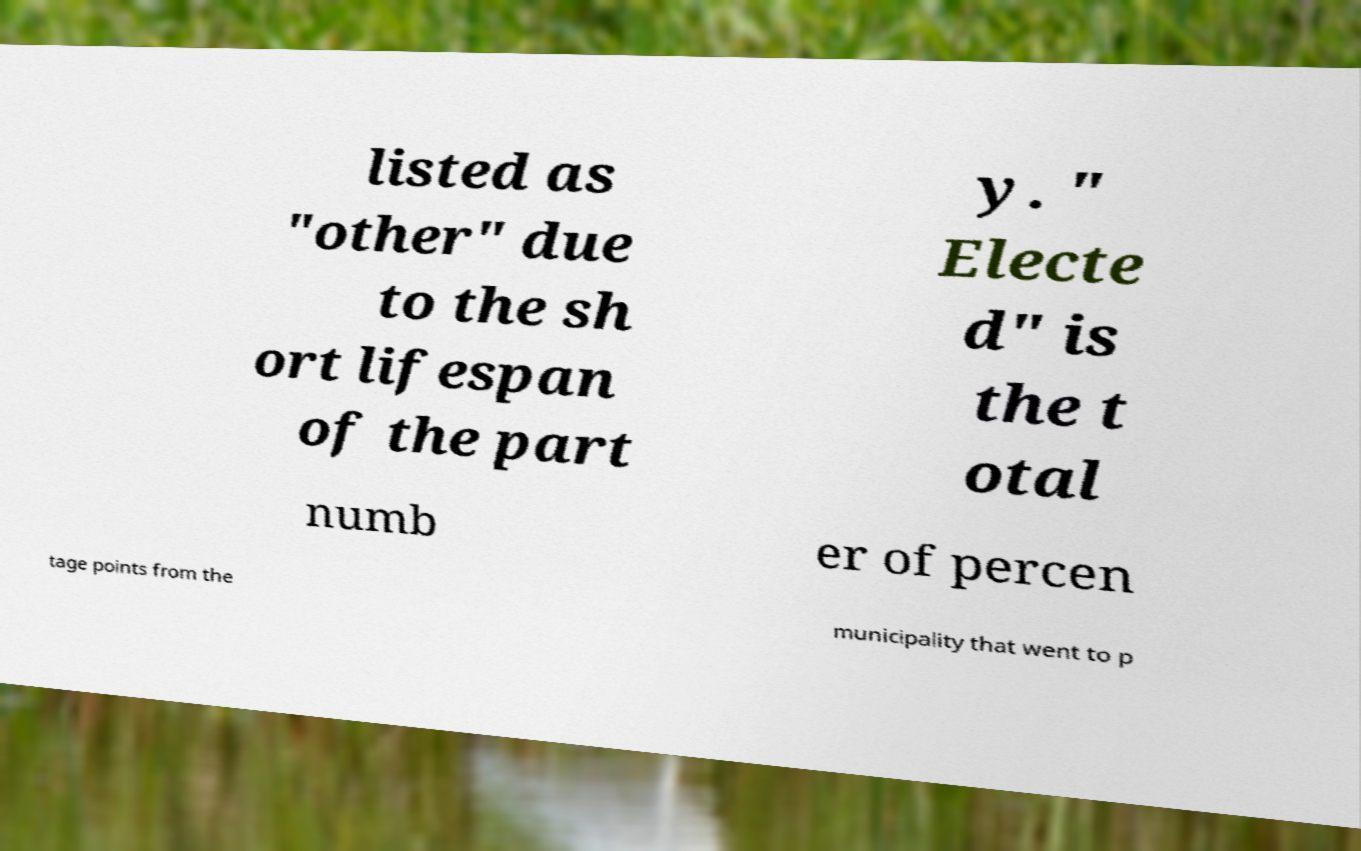Can you accurately transcribe the text from the provided image for me? listed as "other" due to the sh ort lifespan of the part y. " Electe d" is the t otal numb er of percen tage points from the municipality that went to p 